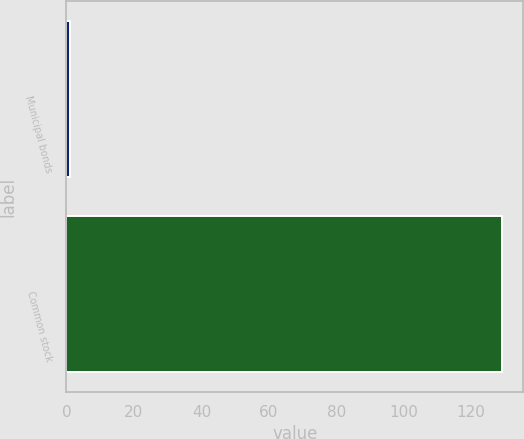<chart> <loc_0><loc_0><loc_500><loc_500><bar_chart><fcel>Municipal bonds<fcel>Common stock<nl><fcel>1<fcel>129<nl></chart> 